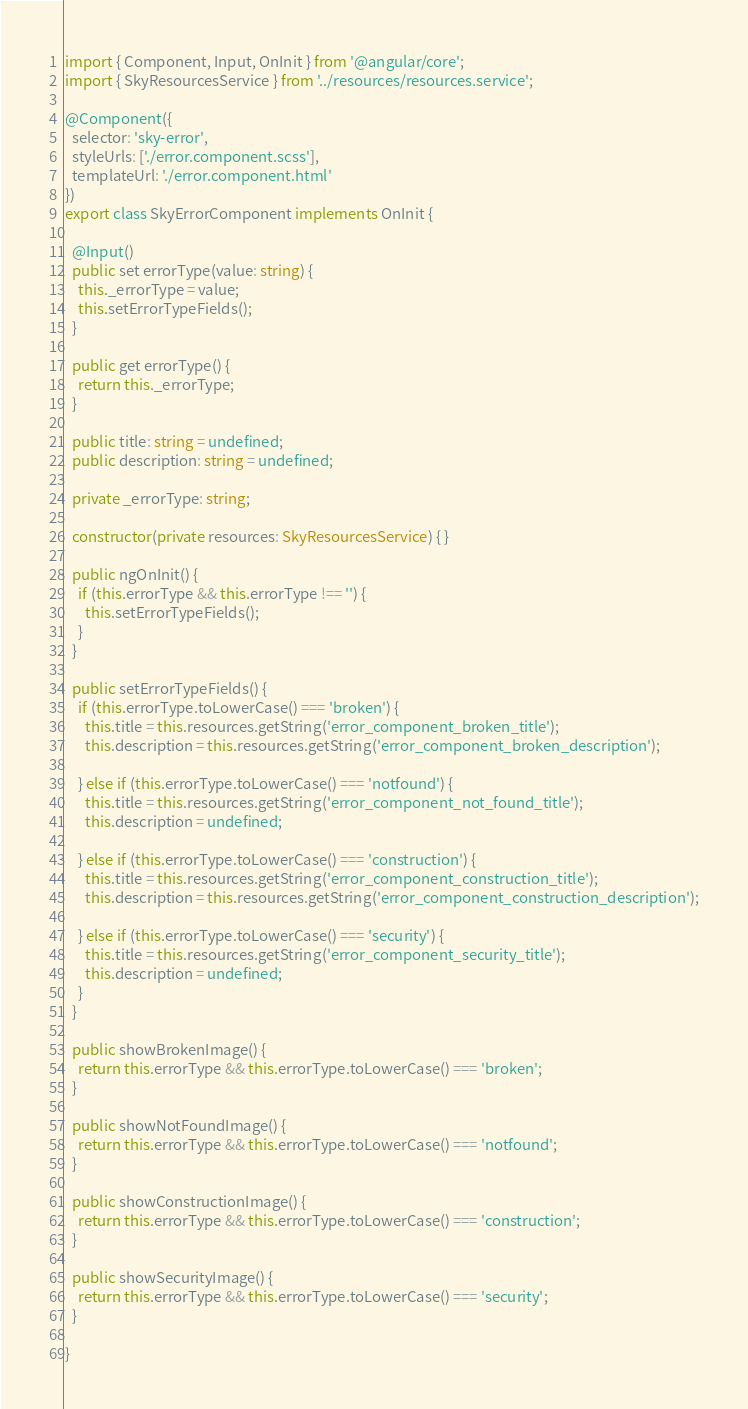<code> <loc_0><loc_0><loc_500><loc_500><_TypeScript_>import { Component, Input, OnInit } from '@angular/core';
import { SkyResourcesService } from '../resources/resources.service';

@Component({
  selector: 'sky-error',
  styleUrls: ['./error.component.scss'],
  templateUrl: './error.component.html'
})
export class SkyErrorComponent implements OnInit {

  @Input()
  public set errorType(value: string) {
    this._errorType = value;
    this.setErrorTypeFields();
  }

  public get errorType() {
    return this._errorType;
  }

  public title: string = undefined;
  public description: string = undefined;

  private _errorType: string;

  constructor(private resources: SkyResourcesService) { }

  public ngOnInit() {
    if (this.errorType && this.errorType !== '') {
      this.setErrorTypeFields();
    }
  }

  public setErrorTypeFields() {
    if (this.errorType.toLowerCase() === 'broken') {
      this.title = this.resources.getString('error_component_broken_title');
      this.description = this.resources.getString('error_component_broken_description');

    } else if (this.errorType.toLowerCase() === 'notfound') {
      this.title = this.resources.getString('error_component_not_found_title');
      this.description = undefined;

    } else if (this.errorType.toLowerCase() === 'construction') {
      this.title = this.resources.getString('error_component_construction_title');
      this.description = this.resources.getString('error_component_construction_description');

    } else if (this.errorType.toLowerCase() === 'security') {
      this.title = this.resources.getString('error_component_security_title');
      this.description = undefined;
    }
  }

  public showBrokenImage() {
    return this.errorType && this.errorType.toLowerCase() === 'broken';
  }

  public showNotFoundImage() {
    return this.errorType && this.errorType.toLowerCase() === 'notfound';
  }

  public showConstructionImage() {
    return this.errorType && this.errorType.toLowerCase() === 'construction';
  }

  public showSecurityImage() {
    return this.errorType && this.errorType.toLowerCase() === 'security';
  }

}
</code> 